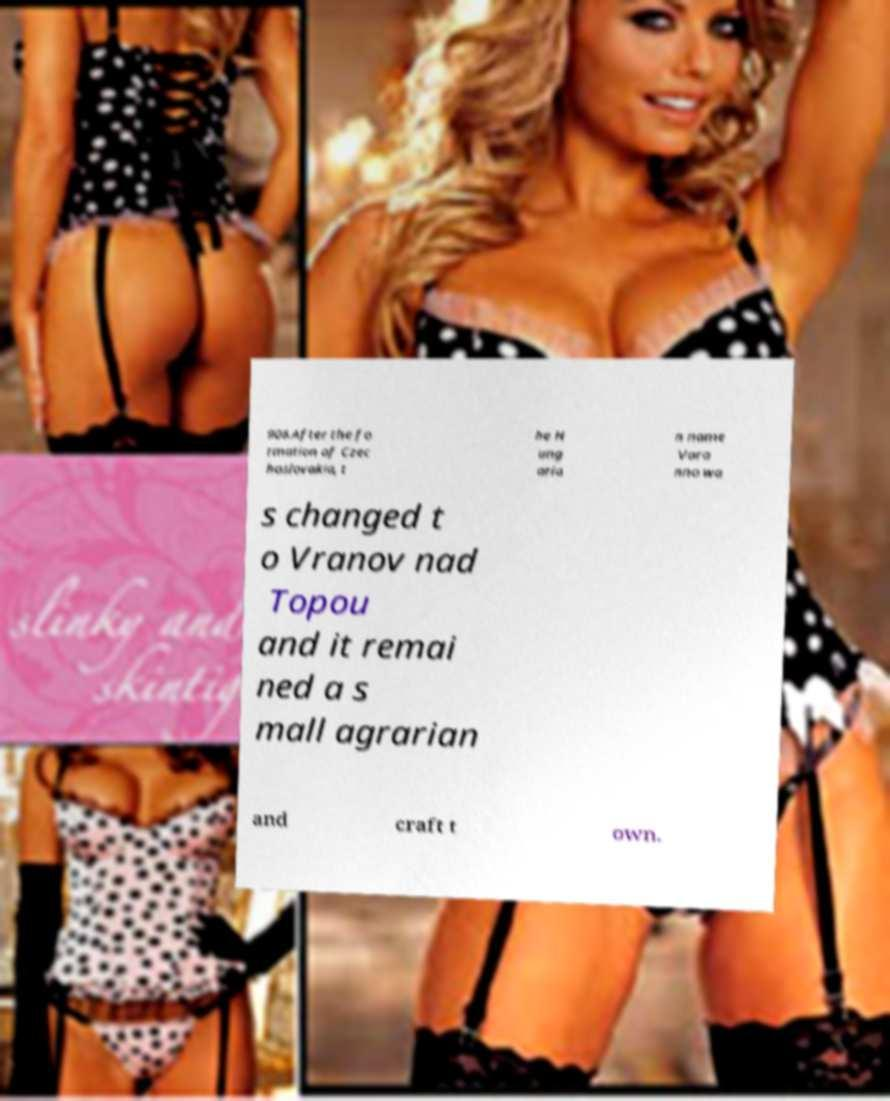There's text embedded in this image that I need extracted. Can you transcribe it verbatim? 906.After the fo rmation of Czec hoslovakia, t he H ung aria n name Vara nno wa s changed t o Vranov nad Topou and it remai ned a s mall agrarian and craft t own. 